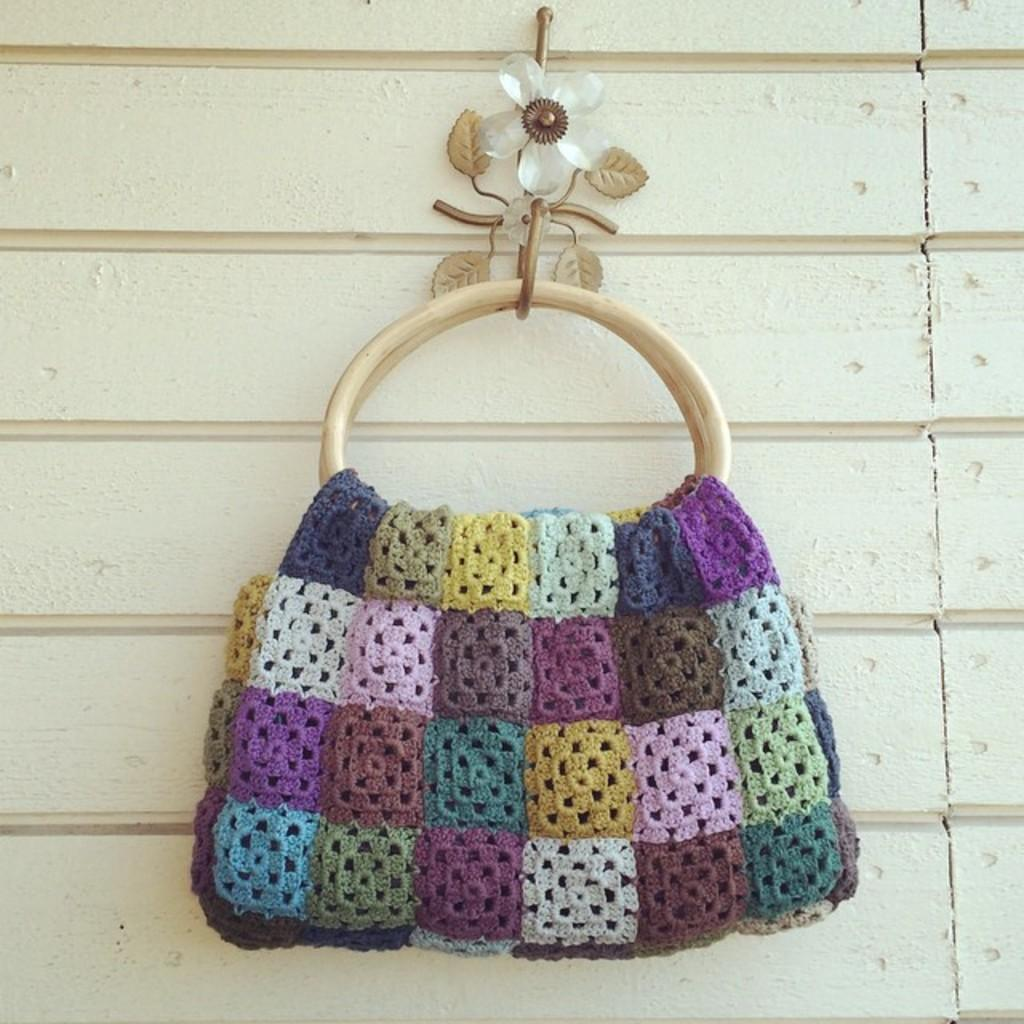What object can be seen in the image? There is a handbag in the image. What type of honey is being used to twist the van's engine in the image? There is no van, honey, or engine present in the image; it only features a handbag. 